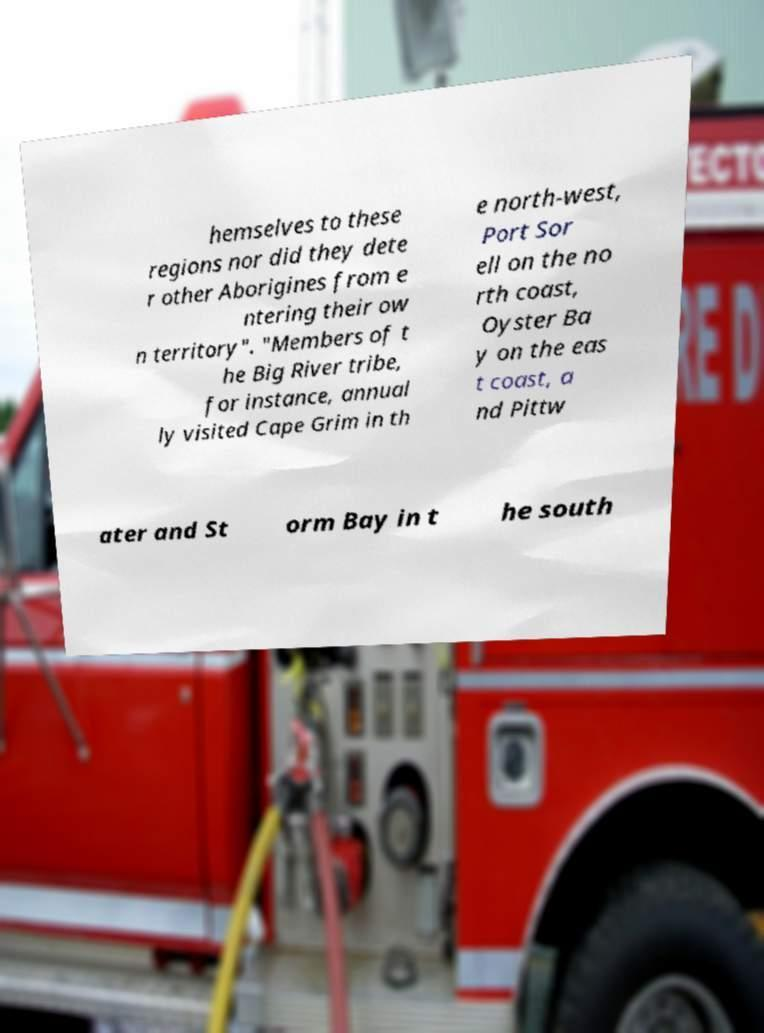For documentation purposes, I need the text within this image transcribed. Could you provide that? hemselves to these regions nor did they dete r other Aborigines from e ntering their ow n territory". "Members of t he Big River tribe, for instance, annual ly visited Cape Grim in th e north-west, Port Sor ell on the no rth coast, Oyster Ba y on the eas t coast, a nd Pittw ater and St orm Bay in t he south 